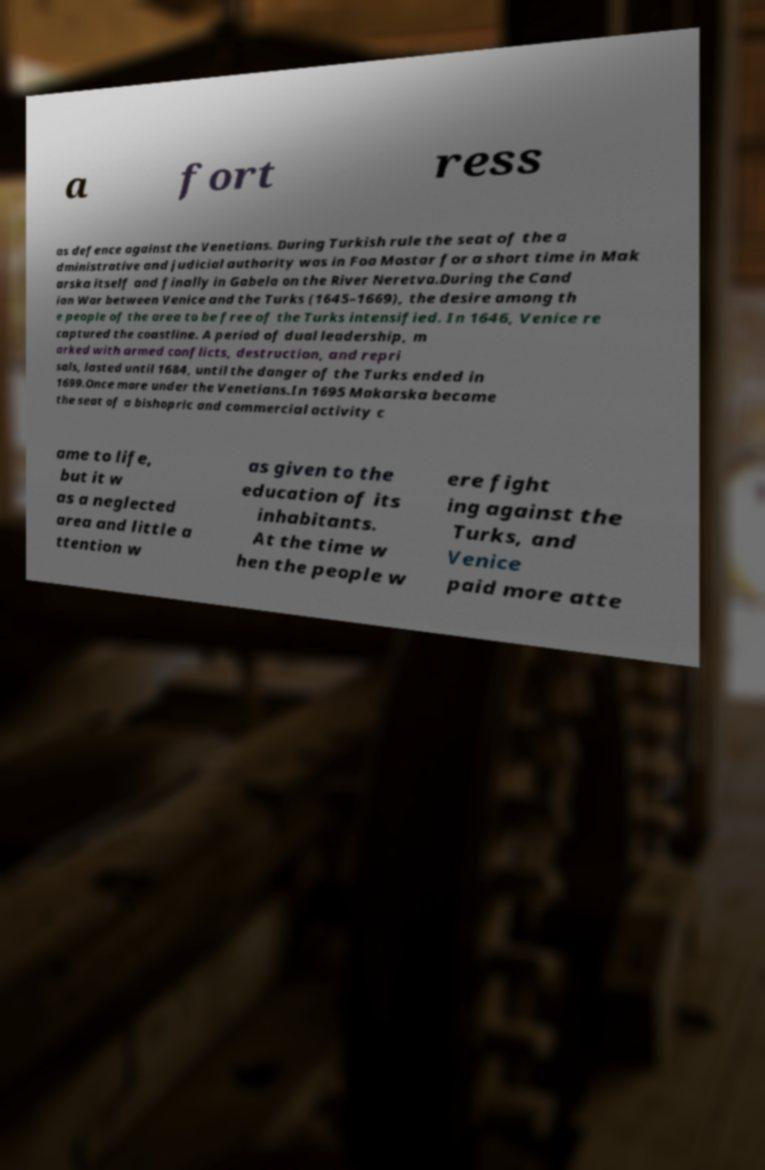For documentation purposes, I need the text within this image transcribed. Could you provide that? a fort ress as defence against the Venetians. During Turkish rule the seat of the a dministrative and judicial authority was in Foa Mostar for a short time in Mak arska itself and finally in Gabela on the River Neretva.During the Cand ian War between Venice and the Turks (1645–1669), the desire among th e people of the area to be free of the Turks intensified. In 1646, Venice re captured the coastline. A period of dual leadership, m arked with armed conflicts, destruction, and repri sals, lasted until 1684, until the danger of the Turks ended in 1699.Once more under the Venetians.In 1695 Makarska became the seat of a bishopric and commercial activity c ame to life, but it w as a neglected area and little a ttention w as given to the education of its inhabitants. At the time w hen the people w ere fight ing against the Turks, and Venice paid more atte 